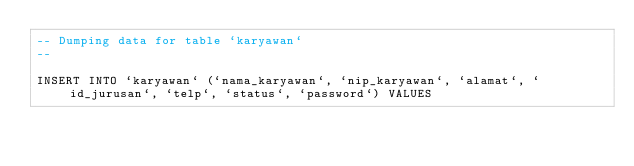Convert code to text. <code><loc_0><loc_0><loc_500><loc_500><_SQL_>-- Dumping data for table `karyawan`
--

INSERT INTO `karyawan` (`nama_karyawan`, `nip_karyawan`, `alamat`, `id_jurusan`, `telp`, `status`, `password`) VALUES</code> 